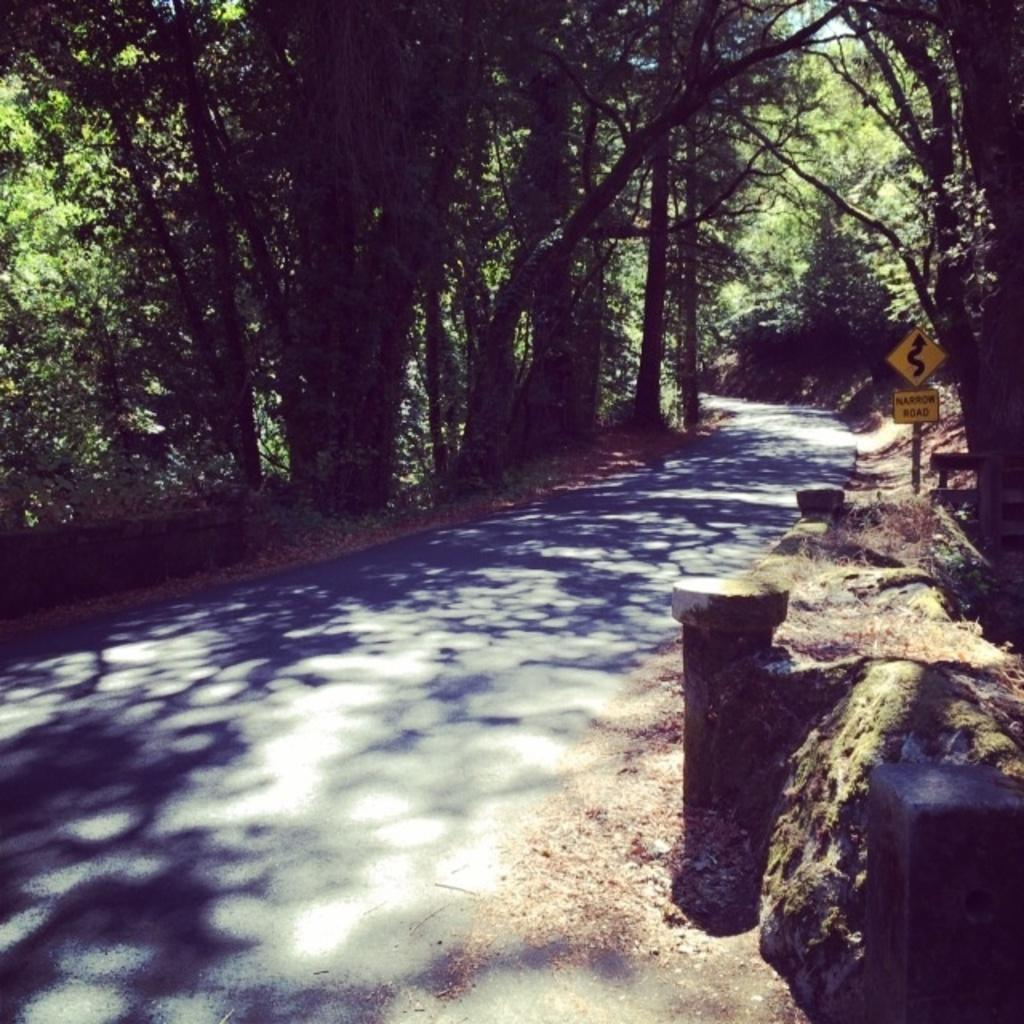What is the main feature of the image? There is a road in the image. What can be seen on the right side of the road? There are boards and a pole on the right side of the road. What type of vegetation is present on both sides of the road? Trees are present on both sides of the road. What is visible in the background of the image? The sky is visible in the background of the image. How many loaves of bread can be seen on the road in the image? There is no bread present in the image; it features a road with trees, boards, and a pole. Is there a judge standing near the pole in the image? There is no judge present in the image; it only features a road, trees, boards, and a pole. 